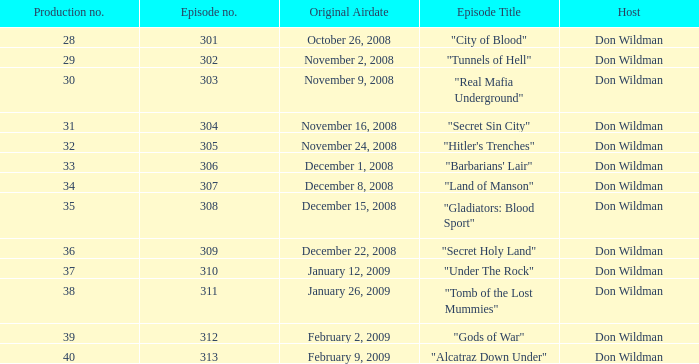What is the episode number of the episode that initially aired on january 26, 2009 and had a production number less than 38? 0.0. 